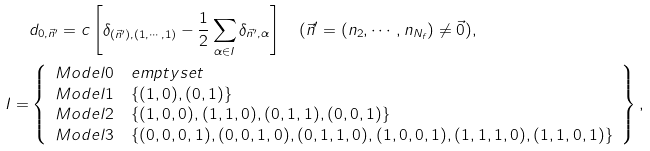<formula> <loc_0><loc_0><loc_500><loc_500>& d _ { 0 , \vec { n } ^ { \prime } } = c \left [ \delta _ { ( \vec { n } ^ { \prime } ) , ( 1 , \cdots , 1 ) } - \frac { 1 } { 2 } \sum _ { \alpha \in I } \delta _ { \vec { n } ^ { \prime } , \alpha } \right ] \quad ( \vec { n } ^ { \prime } = ( n _ { 2 } , \cdots , n _ { N _ { f } } ) \not = \vec { 0 } ) , \\ I = & \left \{ \begin{array} { c l } M o d e l 0 & e m p t y s e t \\ M o d e l 1 & \{ ( 1 , 0 ) , ( 0 , 1 ) \} \\ M o d e l 2 & \{ ( 1 , 0 , 0 ) , ( 1 , 1 , 0 ) , ( 0 , 1 , 1 ) , ( 0 , 0 , 1 ) \} \\ M o d e l 3 & \{ ( 0 , 0 , 0 , 1 ) , ( 0 , 0 , 1 , 0 ) , ( 0 , 1 , 1 , 0 ) , ( 1 , 0 , 0 , 1 ) , ( 1 , 1 , 1 , 0 ) , ( 1 , 1 , 0 , 1 ) \} \end{array} \right \} ,</formula> 